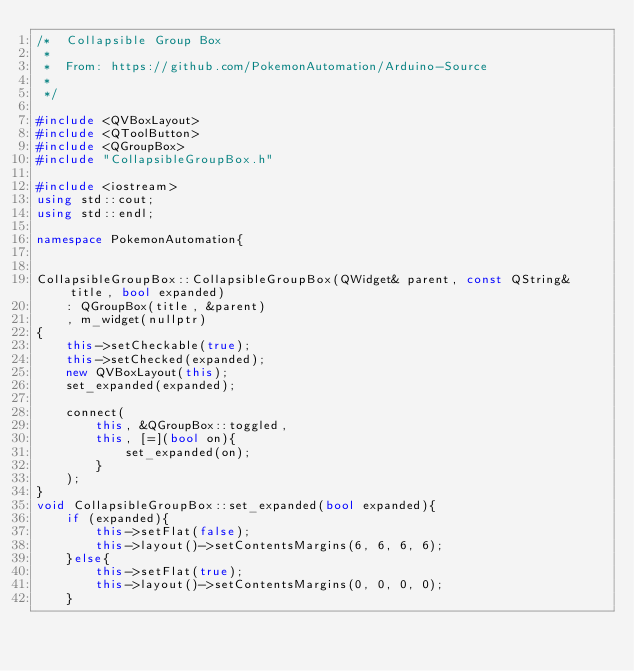<code> <loc_0><loc_0><loc_500><loc_500><_C++_>/*  Collapsible Group Box
 *
 *  From: https://github.com/PokemonAutomation/Arduino-Source
 *
 */

#include <QVBoxLayout>
#include <QToolButton>
#include <QGroupBox>
#include "CollapsibleGroupBox.h"

#include <iostream>
using std::cout;
using std::endl;

namespace PokemonAutomation{


CollapsibleGroupBox::CollapsibleGroupBox(QWidget& parent, const QString& title, bool expanded)
    : QGroupBox(title, &parent)
    , m_widget(nullptr)
{
    this->setCheckable(true);
    this->setChecked(expanded);
    new QVBoxLayout(this);
    set_expanded(expanded);

    connect(
        this, &QGroupBox::toggled,
        this, [=](bool on){
            set_expanded(on);
        }
    );
}
void CollapsibleGroupBox::set_expanded(bool expanded){
    if (expanded){
        this->setFlat(false);
        this->layout()->setContentsMargins(6, 6, 6, 6);
    }else{
        this->setFlat(true);
        this->layout()->setContentsMargins(0, 0, 0, 0);
    }</code> 